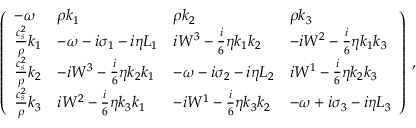<formula> <loc_0><loc_0><loc_500><loc_500>\left ( \begin{array} { l l l l } { - { \omega } } & { \rho k _ { 1 } } & { \rho k _ { 2 } } & { \rho k _ { 3 } } \\ { \frac { c _ { s } ^ { 2 } } { \rho } k _ { 1 } } & { - { \omega } - i \sigma _ { 1 } - i \eta L _ { 1 } } & { i W ^ { 3 } - \frac { i } { 6 } \eta k _ { 1 } k _ { 2 } } & { - i W ^ { 2 } - \frac { i } { 6 } \eta k _ { 1 } k _ { 3 } } \\ { \frac { c _ { s } ^ { 2 } } { \rho } k _ { 2 } } & { - i W ^ { 3 } - \frac { i } { 6 } \eta k _ { 2 } k _ { 1 } } & { - { \omega } - i \sigma _ { 2 } - i \eta L _ { 2 } } & { i W ^ { 1 } - \frac { i } { 6 } \eta k _ { 2 } k _ { 3 } } \\ { \frac { c _ { s } ^ { 2 } } { \rho } k _ { 3 } } & { i W ^ { 2 } - \frac { i } { 6 } \eta k _ { 3 } k _ { 1 } } & { - i W ^ { 1 } - \frac { i } { 6 } \eta k _ { 3 } k _ { 2 } } & { - { \omega } + i \sigma _ { 3 } - i \eta L _ { 3 } } \end{array} \right ) \, ,</formula> 